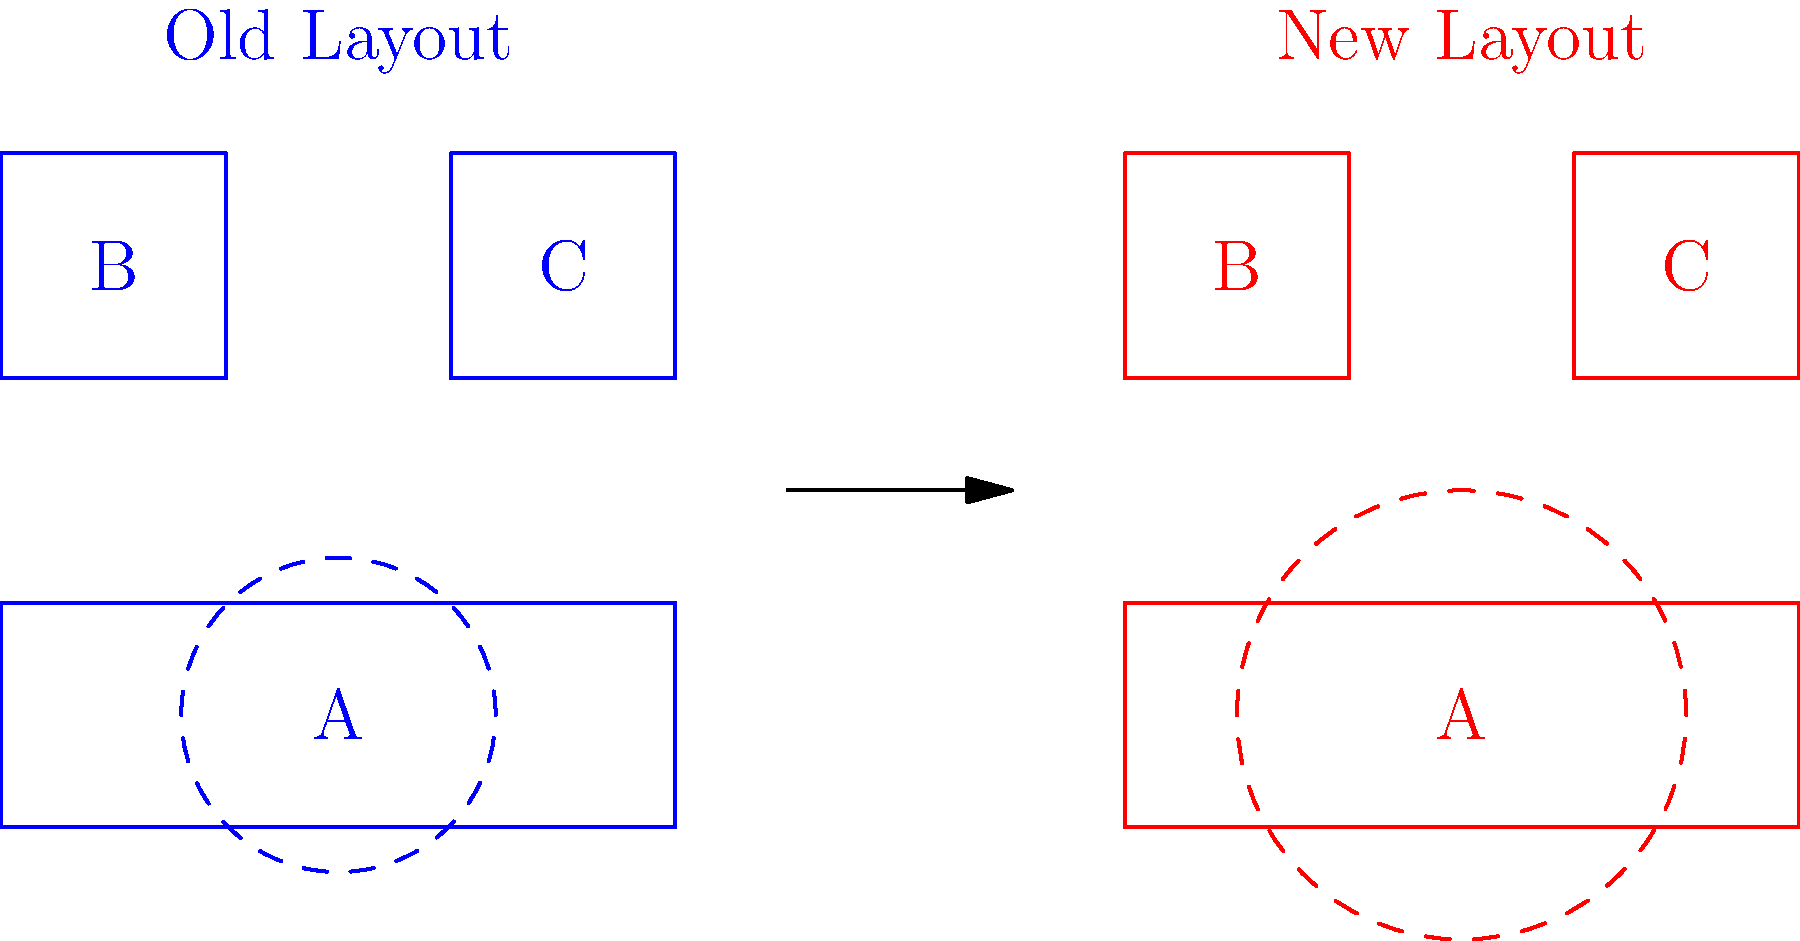Compare the old and new equipment placement diagrams for a production line. The dashed circles represent safety zones around machine A. What is the percentage increase in the safety zone area for machine A in the new layout compared to the old layout? To calculate the percentage increase in the safety zone area, we need to follow these steps:

1. Calculate the area of the safety zone in the old layout:
   Area_old = $\pi r^2$ = $\pi (0.7)^2$ = $1.54\pi$ square units

2. Calculate the area of the safety zone in the new layout:
   Area_new = $\pi r^2$ = $\pi (1)^2$ = $\pi$ square units

3. Calculate the difference in area:
   Difference = Area_new - Area_old = $\pi - 1.54\pi$ = $-0.54\pi$ square units

4. Calculate the percentage increase:
   Percentage increase = $\frac{\text{Difference}}{\text{Area_old}} \times 100\%$
   = $\frac{-0.54\pi}{1.54\pi} \times 100\%$ = $-35.06\%$

5. Convert the negative percentage to a positive increase:
   Actual increase = $100\% - 35.06\%$ = $64.94\%$

Therefore, the safety zone area for machine A in the new layout has increased by approximately 64.94% compared to the old layout.
Answer: 64.94% 